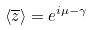Convert formula to latex. <formula><loc_0><loc_0><loc_500><loc_500>\langle \overline { z } \rangle = e ^ { i \mu - \gamma }</formula> 